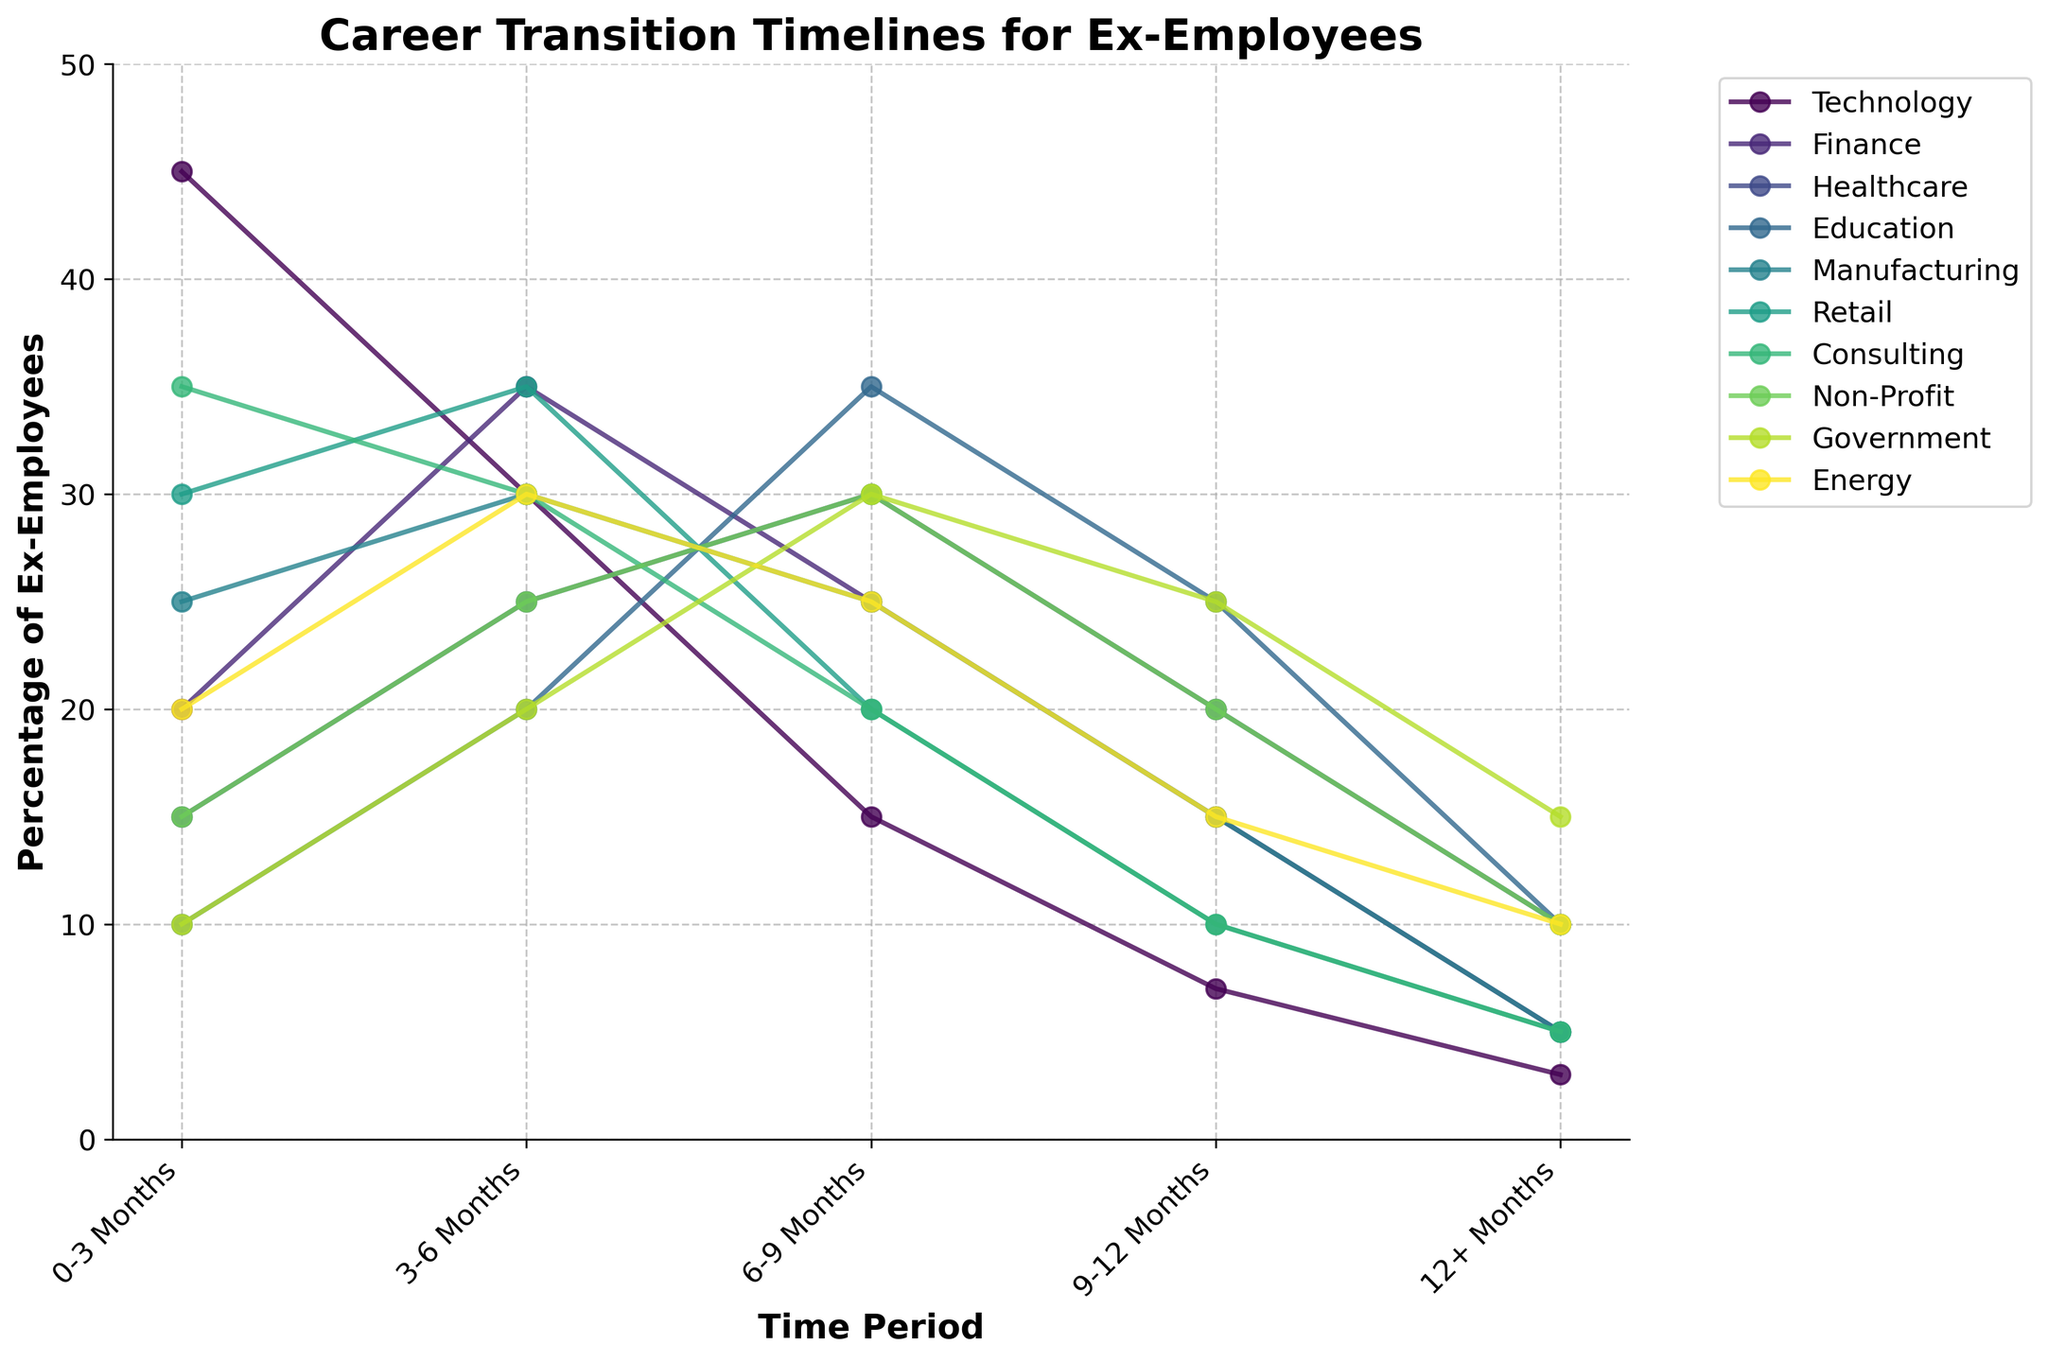Which sector has the highest percentage of ex-employees securing new roles within 0-3 months? Look for the peak of different lines within the 0-3 Months mark on the x-axis. The Technology sector has the highest peak at this point.
Answer: Technology Which sector has the lowest percentage of ex-employees securing new roles within 12+ months? Look for the lowest point among different lines within the 12+ Months mark on the x-axis. The Technology sector is the lowest here.
Answer: Technology Which sector shows the most consistent percentage across the different time periods? Look for the line in the plot that shows minimal fluctuations over different time periods. The Consulting sector appears to have a relatively consistent line.
Answer: Consulting Comparing the Technology and Healthcare sectors, which one has more ex-employees securing roles within 0-6 months? Add the percentage values of 0-3 Months and 3-6 Months for both sectors. Technology: 45 + 30 = 75, Healthcare: 15 + 25 = 40. Technology has more.
Answer: Technology Which time period has the highest average percentage across all sectors? Calculate the average percentage for each time period by summing the percentages across all sectors and then dividing by the number of sectors for each period. The 0-3 Months period has the highest average sum.
Answer: 0-3 Months What is the average percentage of ex-employees across all sectors securing roles within 6-9 months? Add up the 6-9 Months percentages for all sectors and divide by the number of sectors. (15+25+30+35+25+20+20+30+30+25) / 10 = 25.5
Answer: 25.5 Does any sector have an equal percentage of ex-employees securing roles in two different time periods? If yes, which sector and what are the percentages? Look for any lines that have the same y-values at different x-points. For example, Manufacturing has equal 6-9 Months and 9-12 Months percentages (both are 25).
Answer: Manufacturing, 25% In which sector is the percentage of ex-employees securing roles highest in the 9-12 months period? Look for the highest peak among the lines in the 9-12 Months mark on the x-axis. The Education sector has the highest peak at this point.
Answer: Education Which sector has the steepest decline in percentage from the 0-3 months to the 12+ months period? Find the difference between the two periods in the percentages and compare these across all sectors. Technology has the steepest decline (45 - 3 = 42).
Answer: Technology Which sector depicts the second-highest percentage of ex-employees securing roles within the 3-6 months period? Look at the 3-6 Months mark and find the second-highest point. Consulting has the second-highest percentage in this period.
Answer: Consulting 